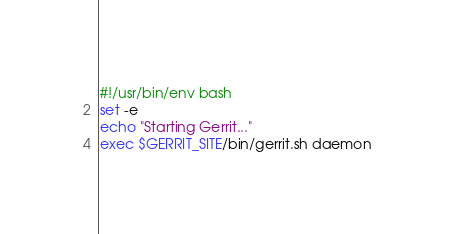<code> <loc_0><loc_0><loc_500><loc_500><_Bash_>#!/usr/bin/env bash
set -e
echo "Starting Gerrit..."
exec $GERRIT_SITE/bin/gerrit.sh daemon

</code> 